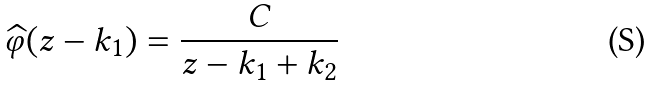<formula> <loc_0><loc_0><loc_500><loc_500>\widehat { \varphi } ( z - k _ { 1 } ) = \frac { C } { z - k _ { 1 } + k _ { 2 } }</formula> 